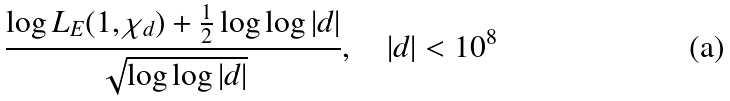Convert formula to latex. <formula><loc_0><loc_0><loc_500><loc_500>\frac { \log L _ { E } ( 1 , \chi _ { d } ) + \frac { 1 } { 2 } \log \log | d | } { \sqrt { \log \log | d | } } , \quad | d | < 1 0 ^ { 8 }</formula> 